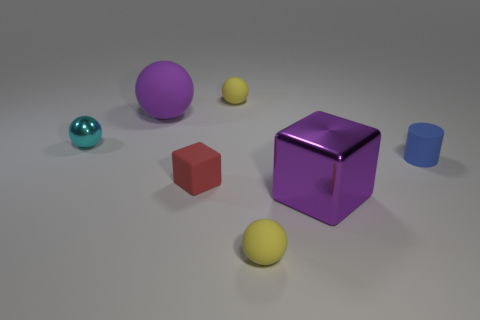The large purple ball left of the large purple object on the right side of the sphere in front of the purple metal thing is made of what material?
Ensure brevity in your answer.  Rubber. Is the number of small yellow spheres behind the tiny blue cylinder greater than the number of cyan shiny spheres?
Provide a succinct answer. No. There is a block that is the same size as the cyan metallic ball; what material is it?
Ensure brevity in your answer.  Rubber. Are there any purple matte balls of the same size as the cyan thing?
Offer a terse response. No. There is a yellow matte ball that is behind the big purple shiny block; how big is it?
Provide a short and direct response. Small. The purple matte ball has what size?
Your answer should be very brief. Large. What number of blocks are tiny shiny objects or big purple metal things?
Your response must be concise. 1. What size is the cylinder that is the same material as the big purple ball?
Make the answer very short. Small. How many other tiny cubes have the same color as the metal block?
Your response must be concise. 0. There is a big purple shiny cube; are there any blocks behind it?
Your answer should be very brief. Yes. 